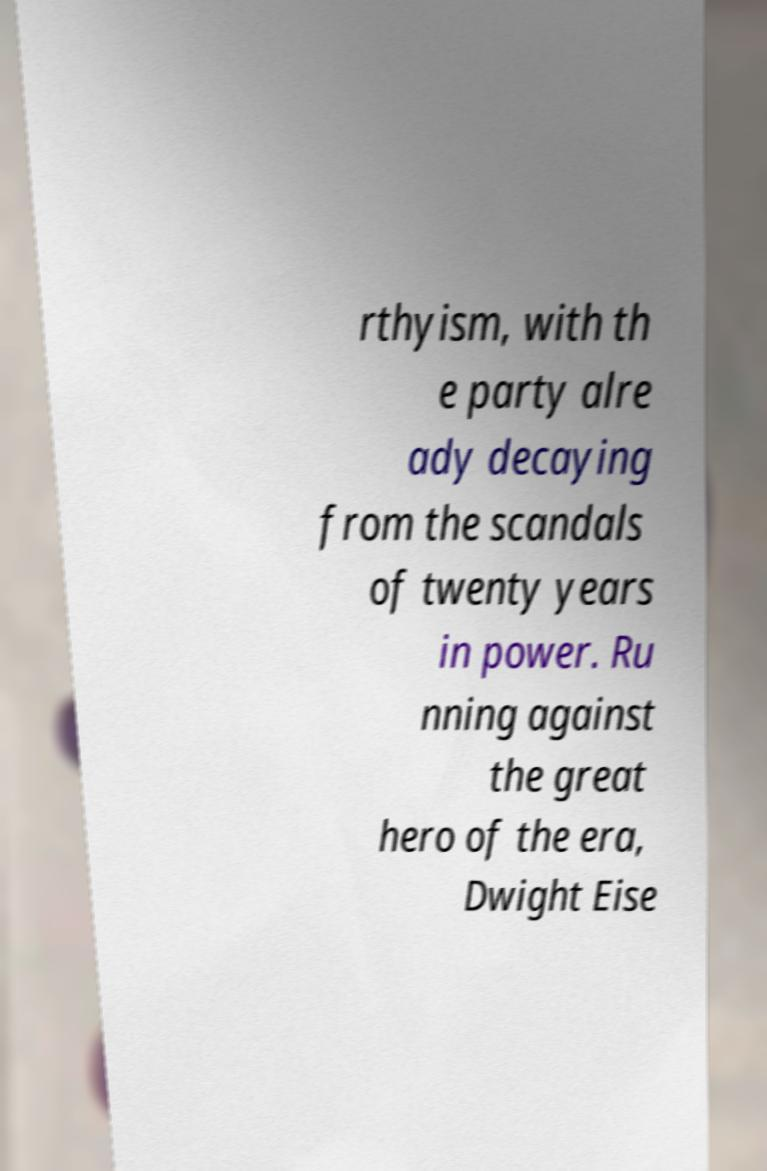For documentation purposes, I need the text within this image transcribed. Could you provide that? rthyism, with th e party alre ady decaying from the scandals of twenty years in power. Ru nning against the great hero of the era, Dwight Eise 